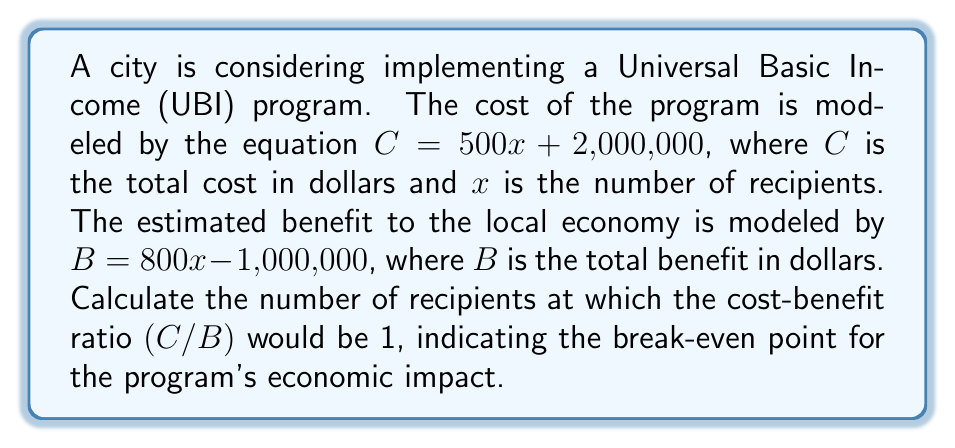Can you answer this question? To solve this problem, we'll follow these steps:

1) The cost-benefit ratio is given by C/B = 1 at the break-even point. We can express this as an equation:

   $$\frac{C}{B} = 1$$

2) Substitute the given equations for C and B:

   $$\frac{500x + 2,000,000}{800x - 1,000,000} = 1$$

3) Multiply both sides by the denominator to eliminate the fraction:

   $$(500x + 2,000,000) = (800x - 1,000,000)$$

4) Expand the brackets:

   $$500x + 2,000,000 = 800x - 1,000,000$$

5) Subtract 500x from both sides:

   $$2,000,000 = 300x - 1,000,000$$

6) Add 1,000,000 to both sides:

   $$3,000,000 = 300x$$

7) Divide both sides by 300:

   $$10,000 = x$$

Therefore, the break-even point occurs when there are 10,000 recipients.
Answer: 10,000 recipients 